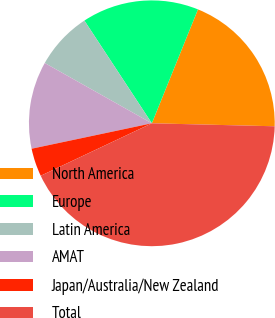Convert chart. <chart><loc_0><loc_0><loc_500><loc_500><pie_chart><fcel>North America<fcel>Europe<fcel>Latin America<fcel>AMAT<fcel>Japan/Australia/New Zealand<fcel>Total<nl><fcel>19.26%<fcel>15.37%<fcel>7.59%<fcel>11.48%<fcel>3.7%<fcel>42.59%<nl></chart> 